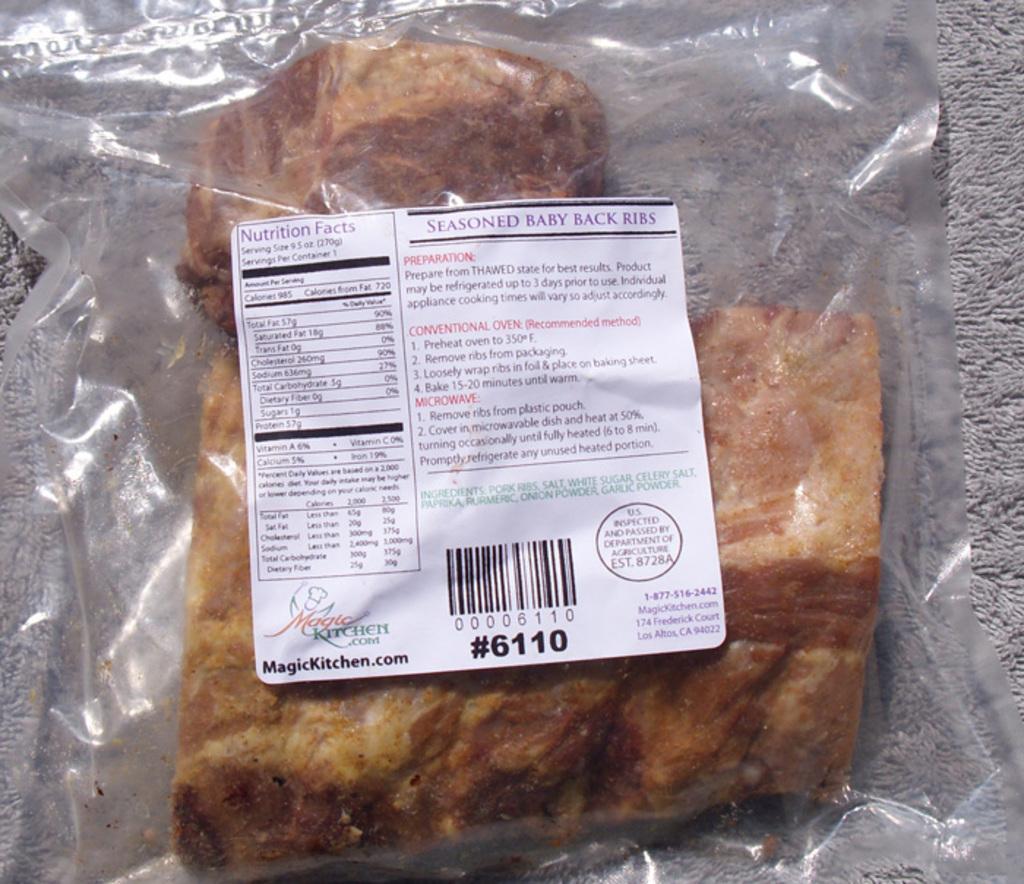How would you summarize this image in a sentence or two? In this picture I can see a food item packed in a plastic cover, there is a sticker on the plastic cover. 